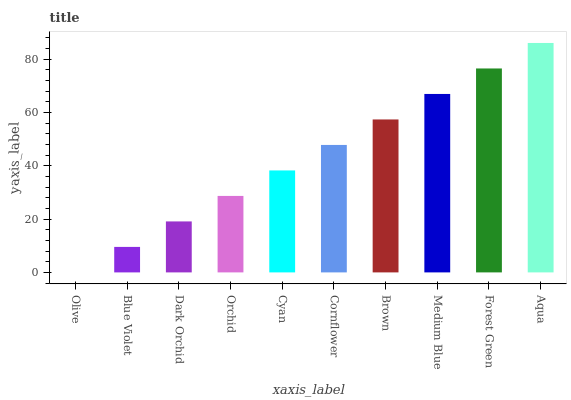Is Olive the minimum?
Answer yes or no. Yes. Is Aqua the maximum?
Answer yes or no. Yes. Is Blue Violet the minimum?
Answer yes or no. No. Is Blue Violet the maximum?
Answer yes or no. No. Is Blue Violet greater than Olive?
Answer yes or no. Yes. Is Olive less than Blue Violet?
Answer yes or no. Yes. Is Olive greater than Blue Violet?
Answer yes or no. No. Is Blue Violet less than Olive?
Answer yes or no. No. Is Cornflower the high median?
Answer yes or no. Yes. Is Cyan the low median?
Answer yes or no. Yes. Is Aqua the high median?
Answer yes or no. No. Is Blue Violet the low median?
Answer yes or no. No. 